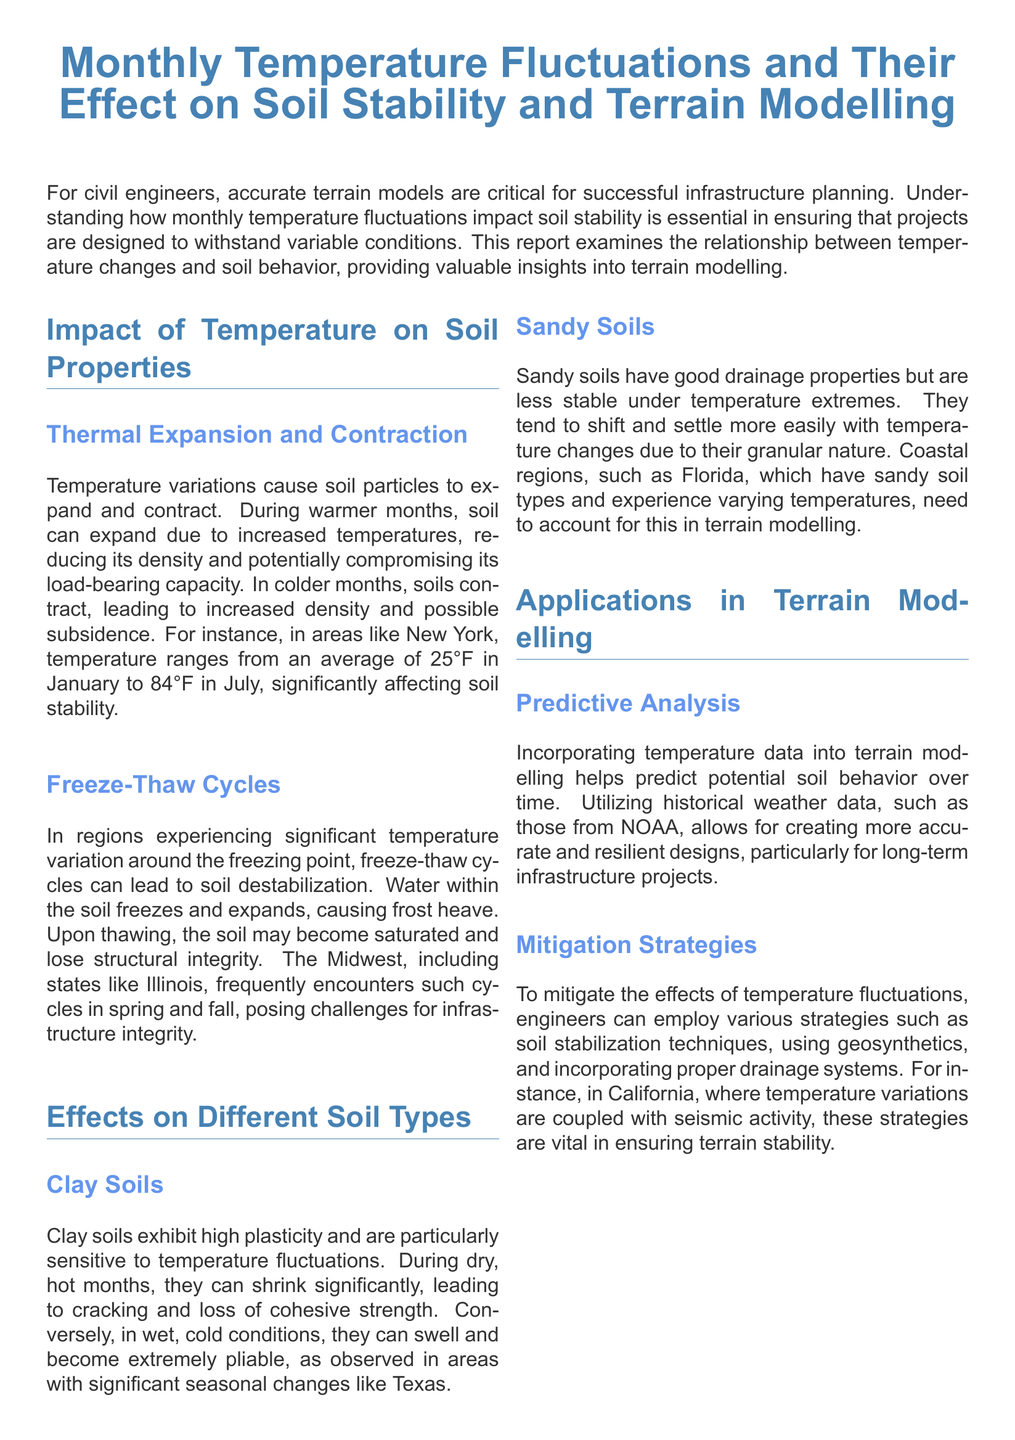What is the primary focus of the report? The report's primary focus is to examine the relationship between temperature changes and soil behavior, providing insights into terrain modelling for civil engineers.
Answer: Relationship between temperature changes and soil behavior What is the average temperature in January in New York? The report states that the average temperature in January in New York is 25°F.
Answer: 25°F Which soil type is particularly sensitive to temperature fluctuations? The report mentions that clay soils exhibit high plasticity and are particularly sensitive to temperature fluctuations.
Answer: Clay soils What phenomenon can lead to soil destabilization in freezing regions? The report explains that freeze-thaw cycles can lead to soil destabilization, causing frost heave.
Answer: Freeze-thaw cycles What strategies can mitigate the effects of temperature fluctuations? The report lists strategies such as soil stabilization techniques, using geosynthetics, and incorporating proper drainage systems as mitigation strategies.
Answer: Soil stabilization, geosynthetics, drainage systems How does sandy soil behave under temperature extremes? The report indicates that sandy soils shift and settle more easily with temperature changes due to their granular nature.
Answer: Shift and settle more easily In which state are freeze-thaw cycles frequently encountered, according to the report? The report notes that states like Illinois frequently encounter freeze-thaw cycles in spring and fall.
Answer: Illinois What is the role of historical weather data in terrain modelling? The report states that incorporating historical weather data helps create more accurate and resilient designs for long-term infrastructure projects.
Answer: Accurate and resilient designs What color represents the headings in the document? The document specifies that the color used for headings is RGB(70, 130, 180).
Answer: RGB(70, 130, 180) 